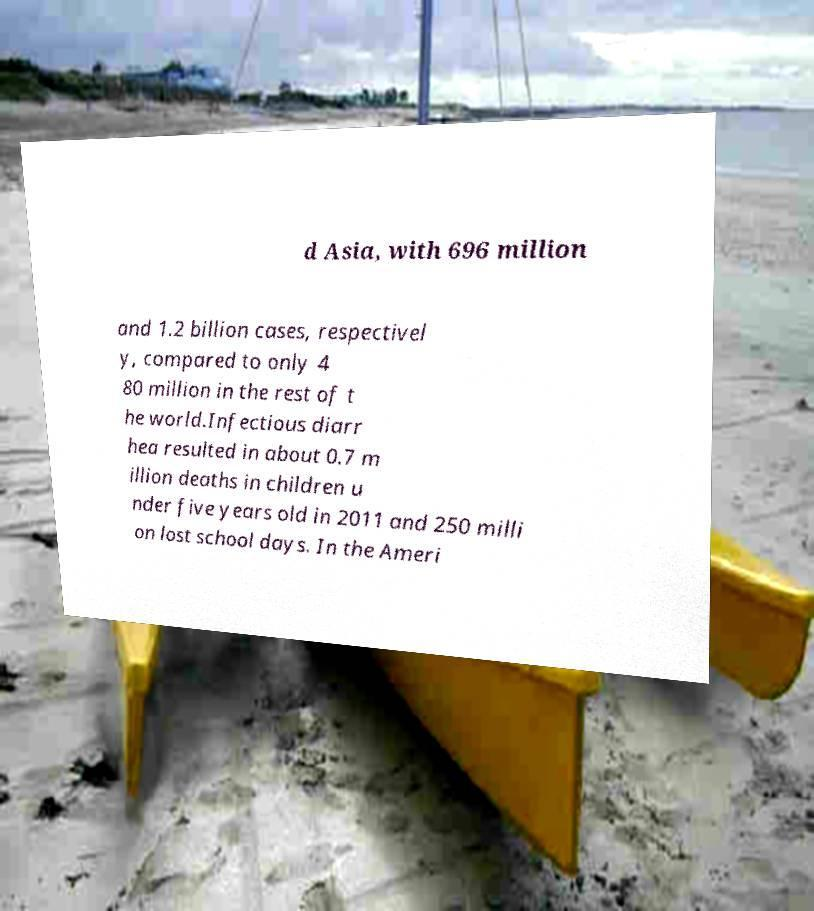Can you read and provide the text displayed in the image?This photo seems to have some interesting text. Can you extract and type it out for me? d Asia, with 696 million and 1.2 billion cases, respectivel y, compared to only 4 80 million in the rest of t he world.Infectious diarr hea resulted in about 0.7 m illion deaths in children u nder five years old in 2011 and 250 milli on lost school days. In the Ameri 